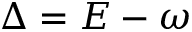Convert formula to latex. <formula><loc_0><loc_0><loc_500><loc_500>\Delta = E - \omega</formula> 